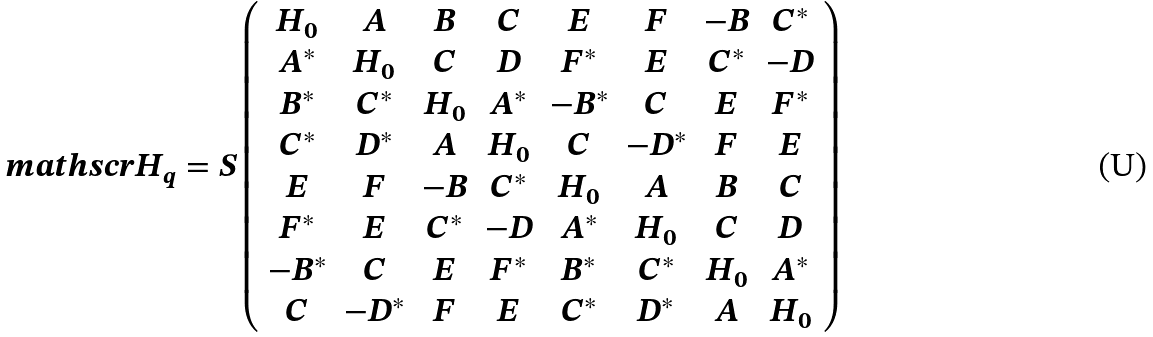<formula> <loc_0><loc_0><loc_500><loc_500>\ m a t h s c r { H } _ { q } = S \left ( \begin{array} { c c c c c c c c } H _ { 0 } & A & B & C & E & F & - B & C ^ { * } \\ A ^ { * } & H _ { 0 } & C & D & F ^ { * } & E & C ^ { * } & - D \\ B ^ { * } & C ^ { * } & H _ { 0 } & A ^ { * } & - B ^ { * } & C & E & F ^ { * } \\ C ^ { * } & D ^ { * } & A & H _ { 0 } & C & - D ^ { * } & F & E \\ E & F & - B & C ^ { * } & H _ { 0 } & A & B & C \\ F ^ { * } & E & C ^ { * } & - D & A ^ { * } & H _ { 0 } & C & D \\ - B ^ { * } & C & E & F ^ { * } & B ^ { * } & C ^ { * } & H _ { 0 } & A ^ { * } \\ C & - D ^ { * } & F & E & C ^ { * } & D ^ { * } & A & H _ { 0 } \\ \end{array} \right )</formula> 